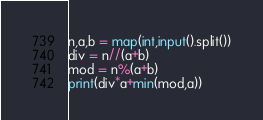Convert code to text. <code><loc_0><loc_0><loc_500><loc_500><_Python_>n,a,b = map(int,input().split())
div = n//(a+b)
mod = n%(a+b)
print(div*a+min(mod,a))</code> 